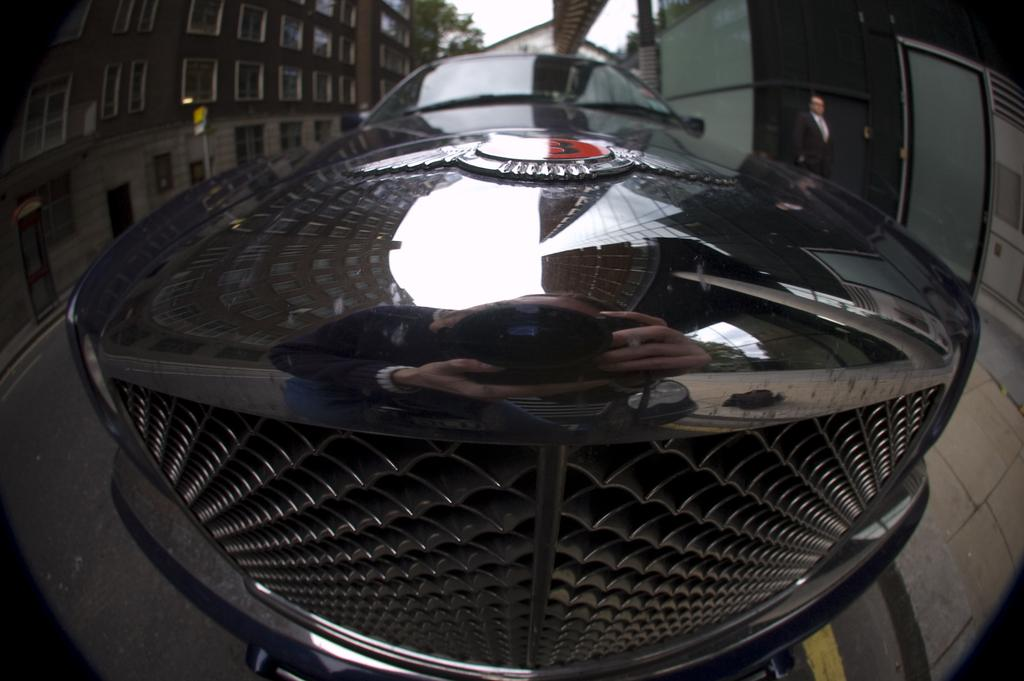What is the main subject of the image? The main subject of the image is a car. Can you describe anything in the background of the image? Yes, there is a man, buildings, and trees in the background of the image. What type of stone can be seen being used to build the end of the quartz structure in the image? There is no stone, end, or quartz structure present in the image. 